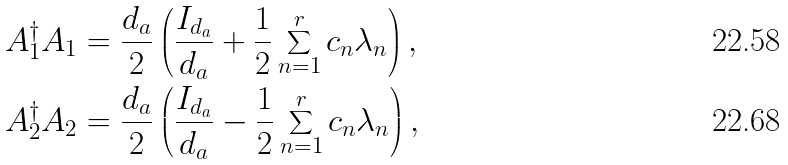Convert formula to latex. <formula><loc_0><loc_0><loc_500><loc_500>A _ { 1 } ^ { \dag } A _ { 1 } & = \frac { d _ { a } } { 2 } \left ( \frac { I _ { d _ { a } } } { d _ { a } } + \frac { 1 } { 2 } \sum _ { n = 1 } ^ { r } c _ { n } \lambda _ { n } \right ) , \\ A _ { 2 } ^ { \dag } A _ { 2 } & = \frac { d _ { a } } { 2 } \left ( \frac { I _ { d _ { a } } } { d _ { a } } - \frac { 1 } { 2 } \sum _ { n = 1 } ^ { r } c _ { n } \lambda _ { n } \right ) ,</formula> 